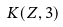<formula> <loc_0><loc_0><loc_500><loc_500>K ( Z , 3 )</formula> 